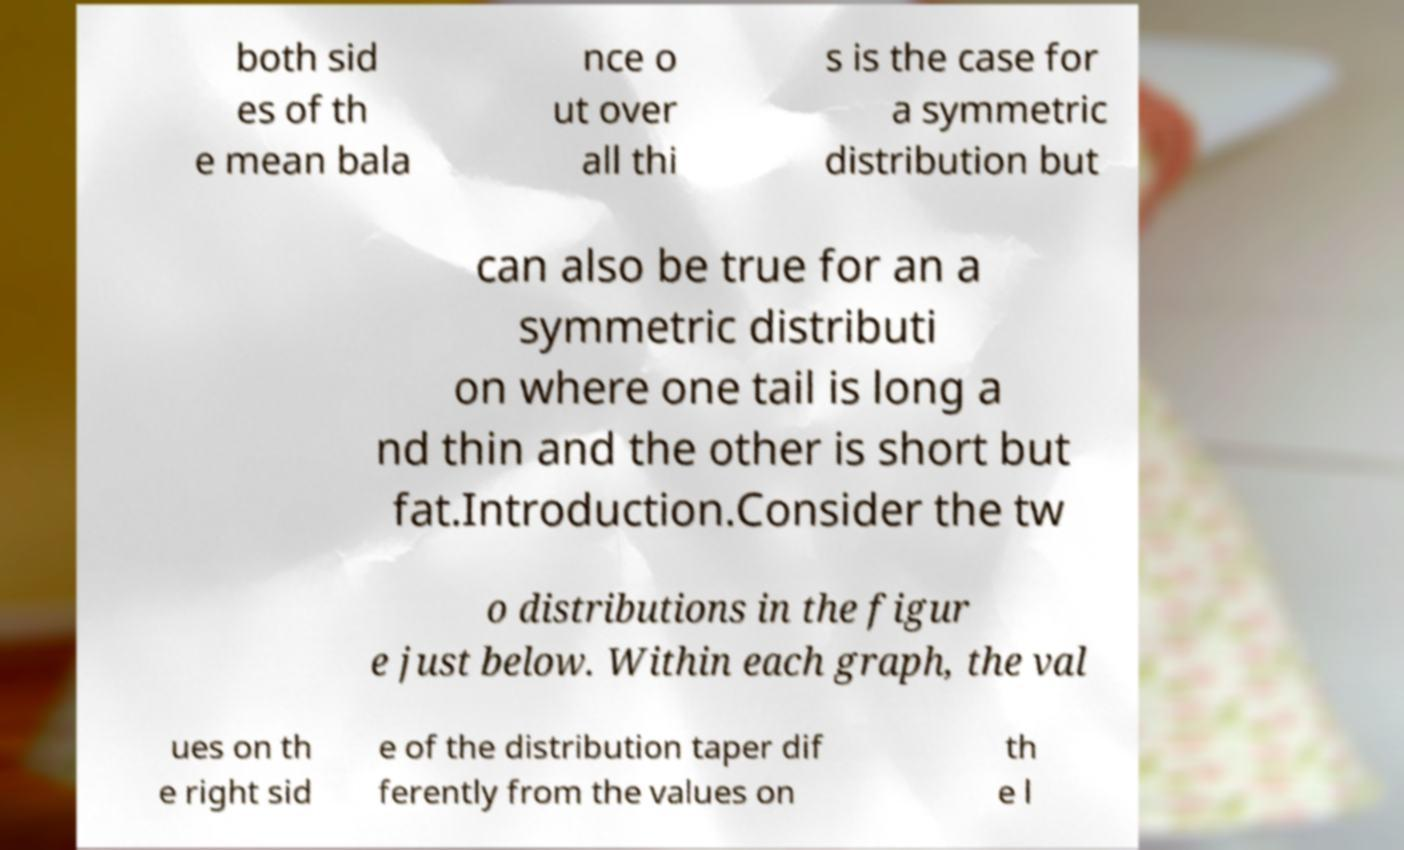Please identify and transcribe the text found in this image. both sid es of th e mean bala nce o ut over all thi s is the case for a symmetric distribution but can also be true for an a symmetric distributi on where one tail is long a nd thin and the other is short but fat.Introduction.Consider the tw o distributions in the figur e just below. Within each graph, the val ues on th e right sid e of the distribution taper dif ferently from the values on th e l 